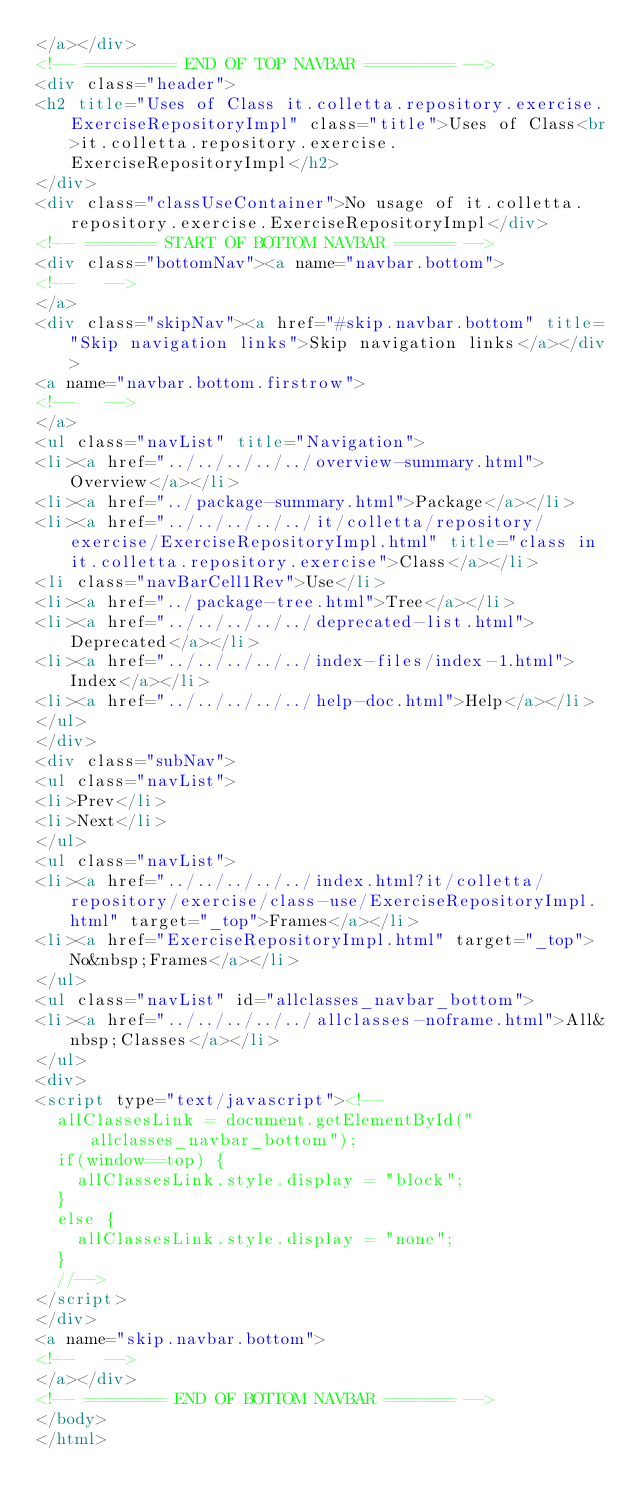Convert code to text. <code><loc_0><loc_0><loc_500><loc_500><_HTML_></a></div>
<!-- ========= END OF TOP NAVBAR ========= -->
<div class="header">
<h2 title="Uses of Class it.colletta.repository.exercise.ExerciseRepositoryImpl" class="title">Uses of Class<br>it.colletta.repository.exercise.ExerciseRepositoryImpl</h2>
</div>
<div class="classUseContainer">No usage of it.colletta.repository.exercise.ExerciseRepositoryImpl</div>
<!-- ======= START OF BOTTOM NAVBAR ====== -->
<div class="bottomNav"><a name="navbar.bottom">
<!--   -->
</a>
<div class="skipNav"><a href="#skip.navbar.bottom" title="Skip navigation links">Skip navigation links</a></div>
<a name="navbar.bottom.firstrow">
<!--   -->
</a>
<ul class="navList" title="Navigation">
<li><a href="../../../../../overview-summary.html">Overview</a></li>
<li><a href="../package-summary.html">Package</a></li>
<li><a href="../../../../../it/colletta/repository/exercise/ExerciseRepositoryImpl.html" title="class in it.colletta.repository.exercise">Class</a></li>
<li class="navBarCell1Rev">Use</li>
<li><a href="../package-tree.html">Tree</a></li>
<li><a href="../../../../../deprecated-list.html">Deprecated</a></li>
<li><a href="../../../../../index-files/index-1.html">Index</a></li>
<li><a href="../../../../../help-doc.html">Help</a></li>
</ul>
</div>
<div class="subNav">
<ul class="navList">
<li>Prev</li>
<li>Next</li>
</ul>
<ul class="navList">
<li><a href="../../../../../index.html?it/colletta/repository/exercise/class-use/ExerciseRepositoryImpl.html" target="_top">Frames</a></li>
<li><a href="ExerciseRepositoryImpl.html" target="_top">No&nbsp;Frames</a></li>
</ul>
<ul class="navList" id="allclasses_navbar_bottom">
<li><a href="../../../../../allclasses-noframe.html">All&nbsp;Classes</a></li>
</ul>
<div>
<script type="text/javascript"><!--
  allClassesLink = document.getElementById("allclasses_navbar_bottom");
  if(window==top) {
    allClassesLink.style.display = "block";
  }
  else {
    allClassesLink.style.display = "none";
  }
  //-->
</script>
</div>
<a name="skip.navbar.bottom">
<!--   -->
</a></div>
<!-- ======== END OF BOTTOM NAVBAR ======= -->
</body>
</html>
</code> 